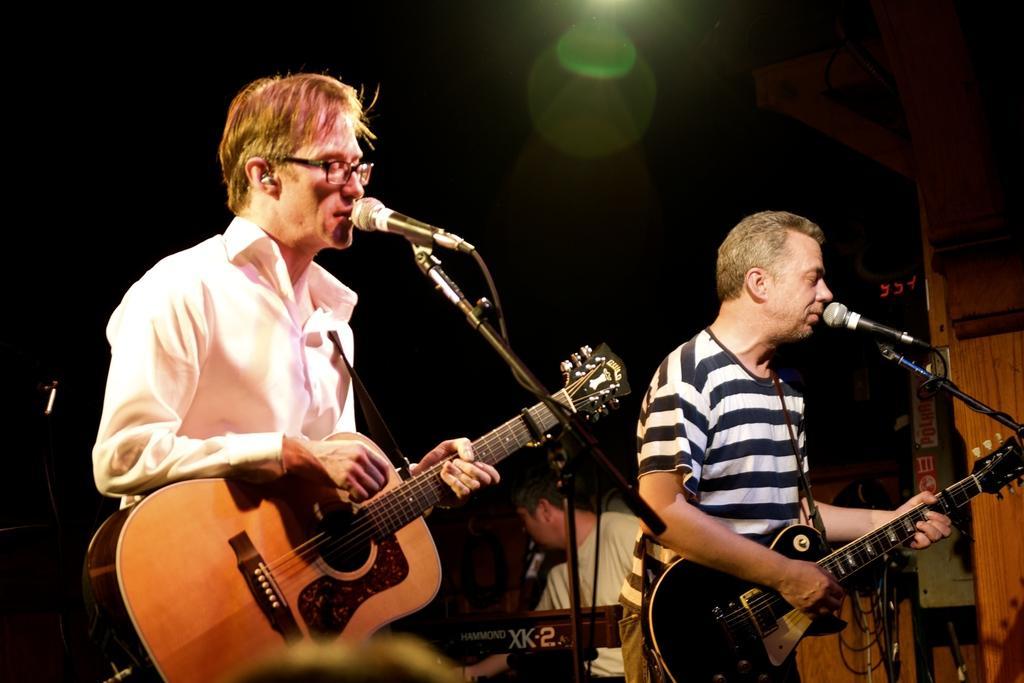Could you give a brief overview of what you see in this image? It looks like event inside the club there are total three men , first man wearing white shirt is playing guitar and singing the song second person also doing the same thing behind them the third person is sitting and playing piano ,the background is dark and there is a green color light. 